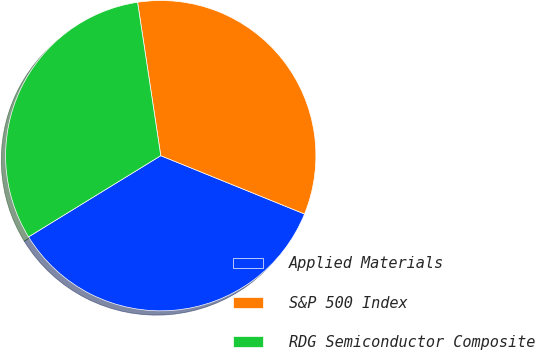Convert chart. <chart><loc_0><loc_0><loc_500><loc_500><pie_chart><fcel>Applied Materials<fcel>S&P 500 Index<fcel>RDG Semiconductor Composite<nl><fcel>35.1%<fcel>33.52%<fcel>31.38%<nl></chart> 